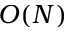<formula> <loc_0><loc_0><loc_500><loc_500>O ( N )</formula> 